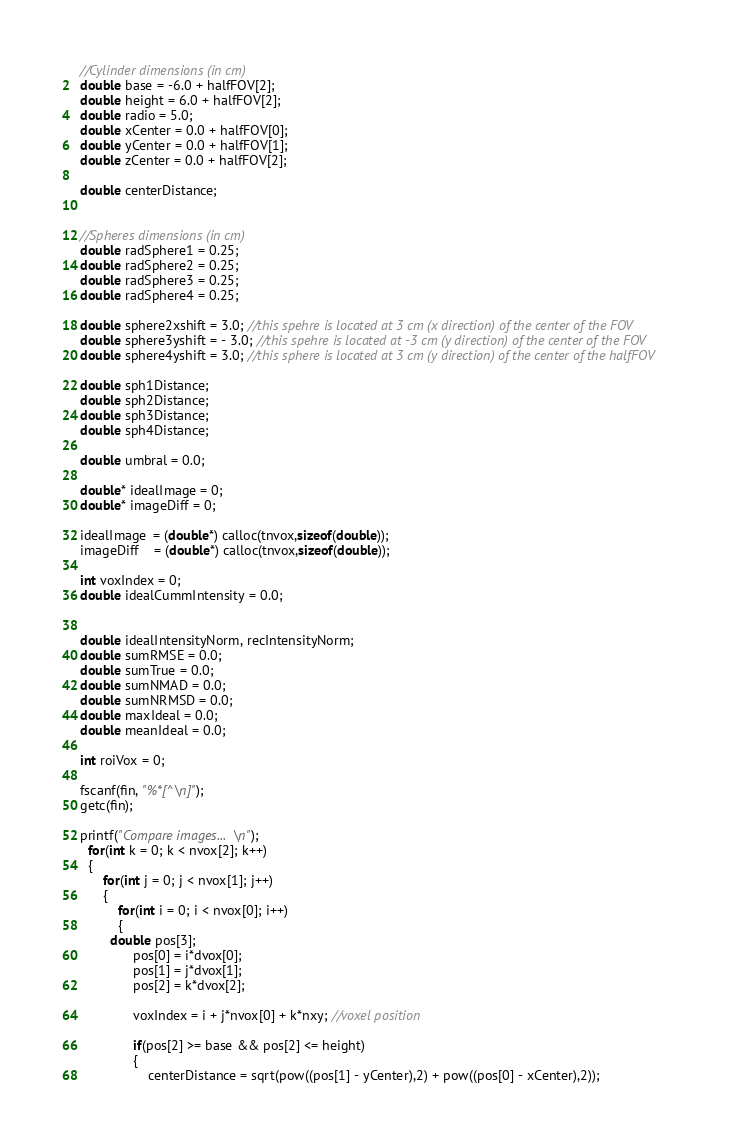<code> <loc_0><loc_0><loc_500><loc_500><_C++_>  //Cylinder dimensions (in cm)
  double base = -6.0 + halfFOV[2]; 
  double height = 6.0 + halfFOV[2];
  double radio = 5.0;
  double xCenter = 0.0 + halfFOV[0];
  double yCenter = 0.0 + halfFOV[1];
  double zCenter = 0.0 + halfFOV[2];
    
  double centerDistance;
    
    
  //Spheres dimensions (in cm)
  double radSphere1 = 0.25;
  double radSphere2 = 0.25; 
  double radSphere3 = 0.25;
  double radSphere4 = 0.25;
    
  double sphere2xshift = 3.0; //this spehre is located at 3 cm (x direction) of the center of the FOV
  double sphere3yshift = - 3.0; //this spehre is located at -3 cm (y direction) of the center of the FOV
  double sphere4yshift = 3.0; //this sphere is located at 3 cm (y direction) of the center of the halfFOV
    
  double sph1Distance;
  double sph2Distance;
  double sph3Distance;
  double sph4Distance;  
    
  double umbral = 0.0;
  
  double* idealImage = 0;
  double* imageDiff = 0;
  
  idealImage  = (double*) calloc(tnvox,sizeof(double));
  imageDiff    = (double*) calloc(tnvox,sizeof(double));

  int voxIndex = 0;
  double idealCummIntensity = 0.0;
  
  
  double idealIntensityNorm, recIntensityNorm;
  double sumRMSE = 0.0;
  double sumTrue = 0.0;
  double sumNMAD = 0.0;
  double sumNRMSD = 0.0;
  double maxIdeal = 0.0;
  double meanIdeal = 0.0;
  
  int roiVox = 0;
    
  fscanf(fin, "%*[^\n]");
  getc(fin);

  printf("Compare images...\n");
    for(int k = 0; k < nvox[2]; k++)
    {
        for(int j = 0; j < nvox[1]; j++)
        {
            for(int i = 0; i < nvox[0]; i++)
            {
	      double pos[3];
                pos[0] = i*dvox[0];
                pos[1] = j*dvox[1];
                pos[2] = k*dvox[2];
                
                voxIndex = i + j*nvox[0] + k*nxy; //voxel position
                
                if(pos[2] >= base && pos[2] <= height)
                {
                    centerDistance = sqrt(pow((pos[1] - yCenter),2) + pow((pos[0] - xCenter),2));</code> 